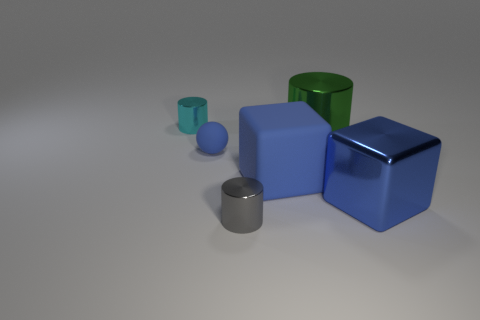Subtract all large metal cylinders. How many cylinders are left? 2 Add 1 small cyan shiny things. How many objects exist? 7 Subtract all spheres. How many objects are left? 5 Subtract all small objects. Subtract all big blue metal cubes. How many objects are left? 2 Add 2 large green cylinders. How many large green cylinders are left? 3 Add 4 big blue shiny objects. How many big blue shiny objects exist? 5 Subtract 0 purple spheres. How many objects are left? 6 